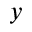Convert formula to latex. <formula><loc_0><loc_0><loc_500><loc_500>y</formula> 